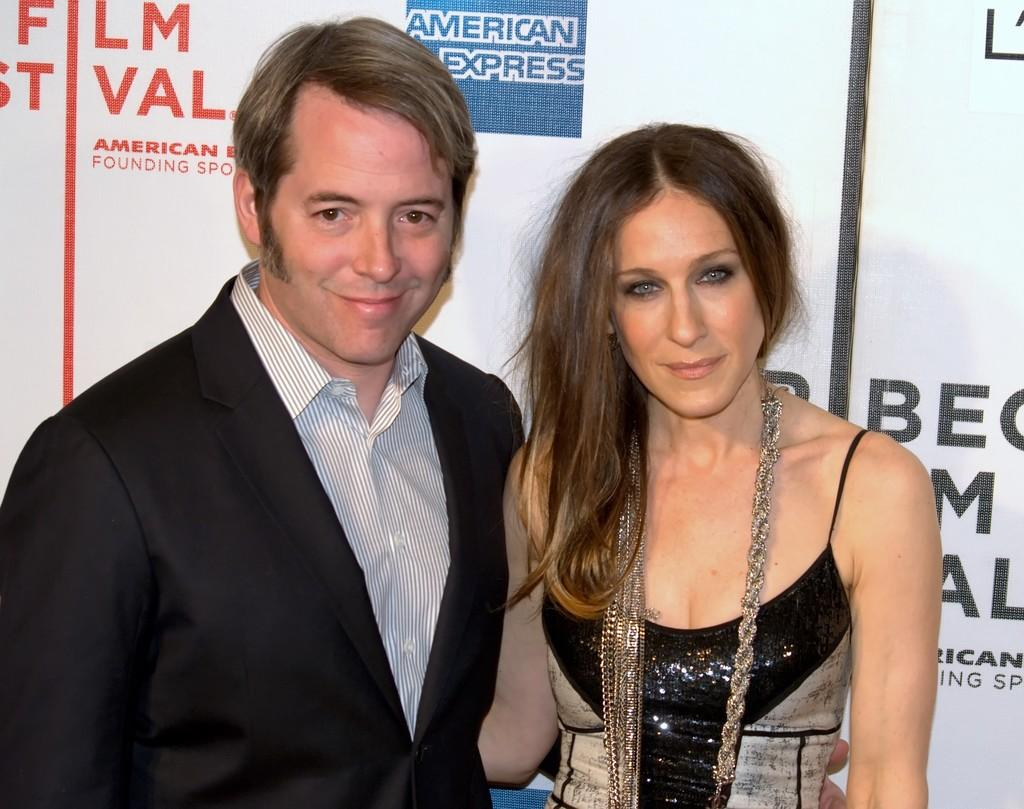Who is present in the image? There is a man and a woman in the image. What are the man and woman doing in the image? The man and woman are standing together and smiling. What can be seen in the background of the image? There is a banner in the image. What channel is the man and woman watching in the image? There is no television or channel visible in the image; it only shows the man and woman standing together and smiling. 